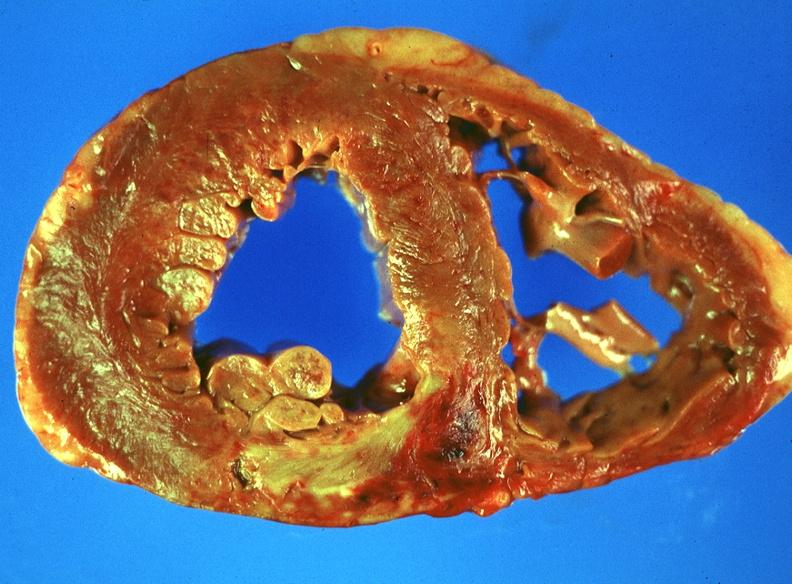s vasculature present?
Answer the question using a single word or phrase. No 